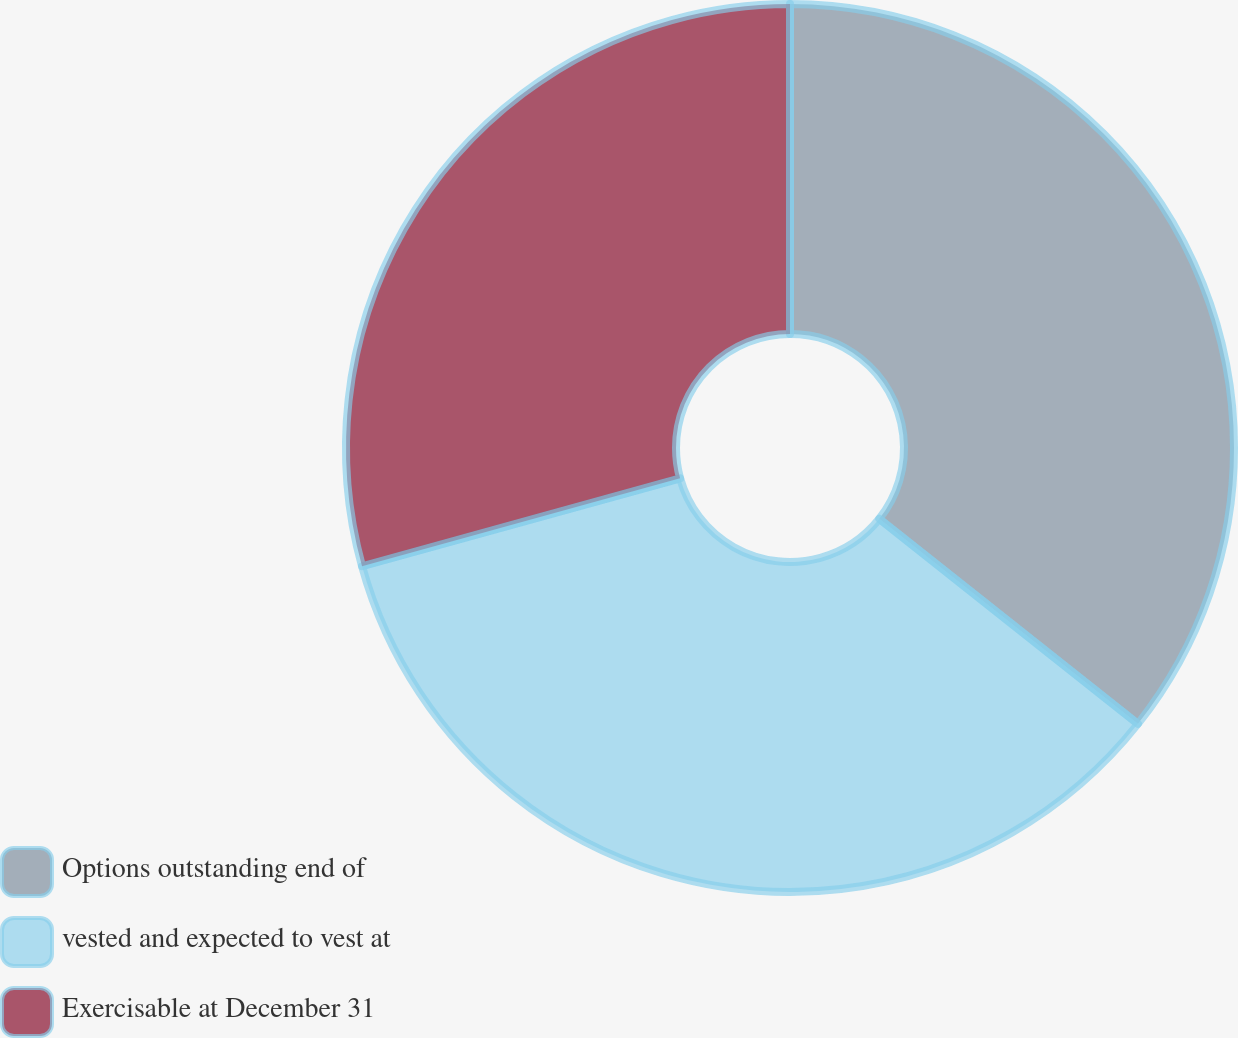<chart> <loc_0><loc_0><loc_500><loc_500><pie_chart><fcel>Options outstanding end of<fcel>vested and expected to vest at<fcel>Exercisable at December 31<nl><fcel>35.67%<fcel>35.04%<fcel>29.29%<nl></chart> 